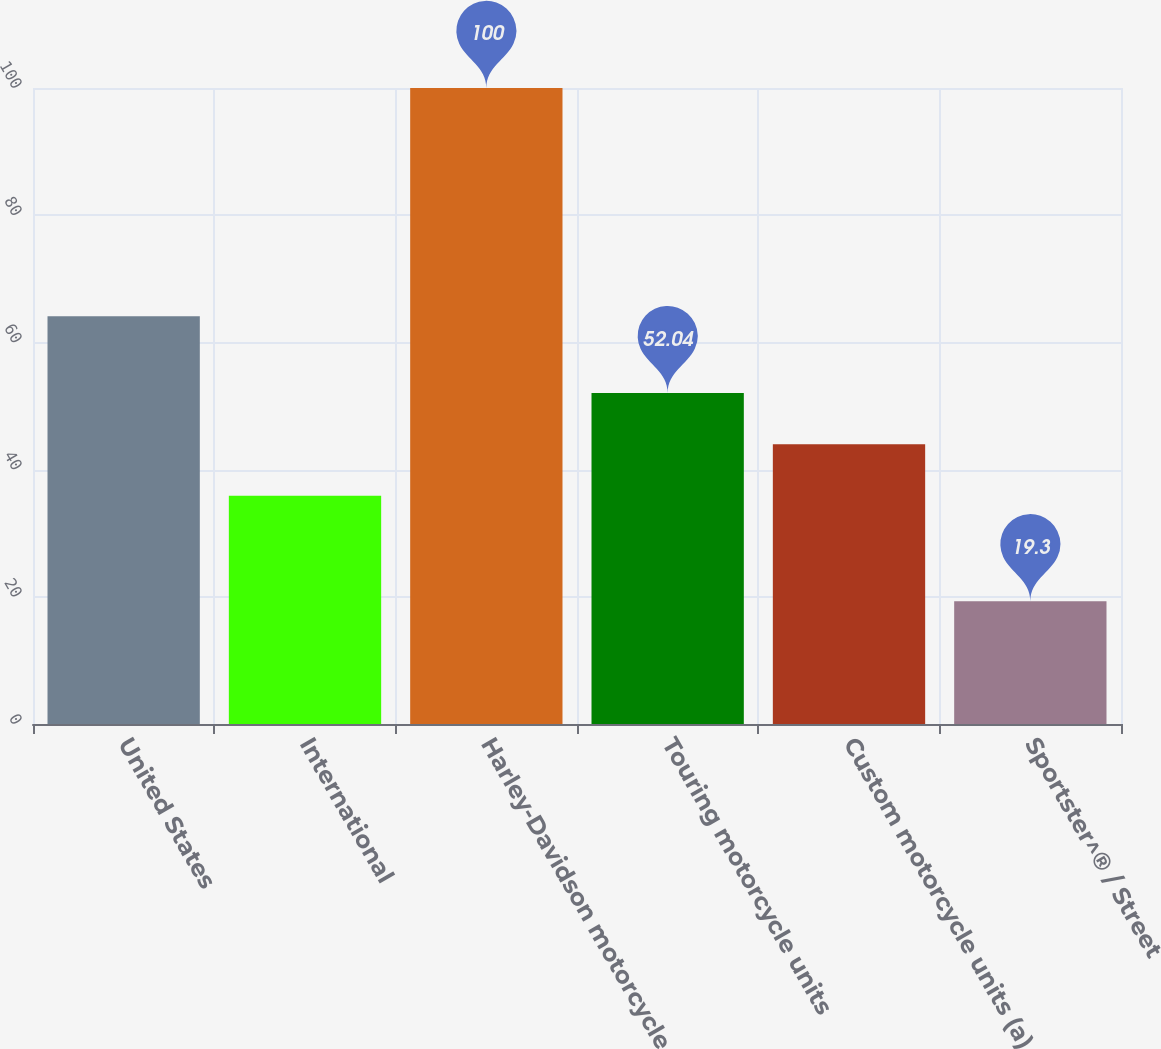Convert chart. <chart><loc_0><loc_0><loc_500><loc_500><bar_chart><fcel>United States<fcel>International<fcel>Harley-Davidson motorcycle<fcel>Touring motorcycle units<fcel>Custom motorcycle units (a)<fcel>Sportster^® / Street<nl><fcel>64.1<fcel>35.9<fcel>100<fcel>52.04<fcel>43.97<fcel>19.3<nl></chart> 